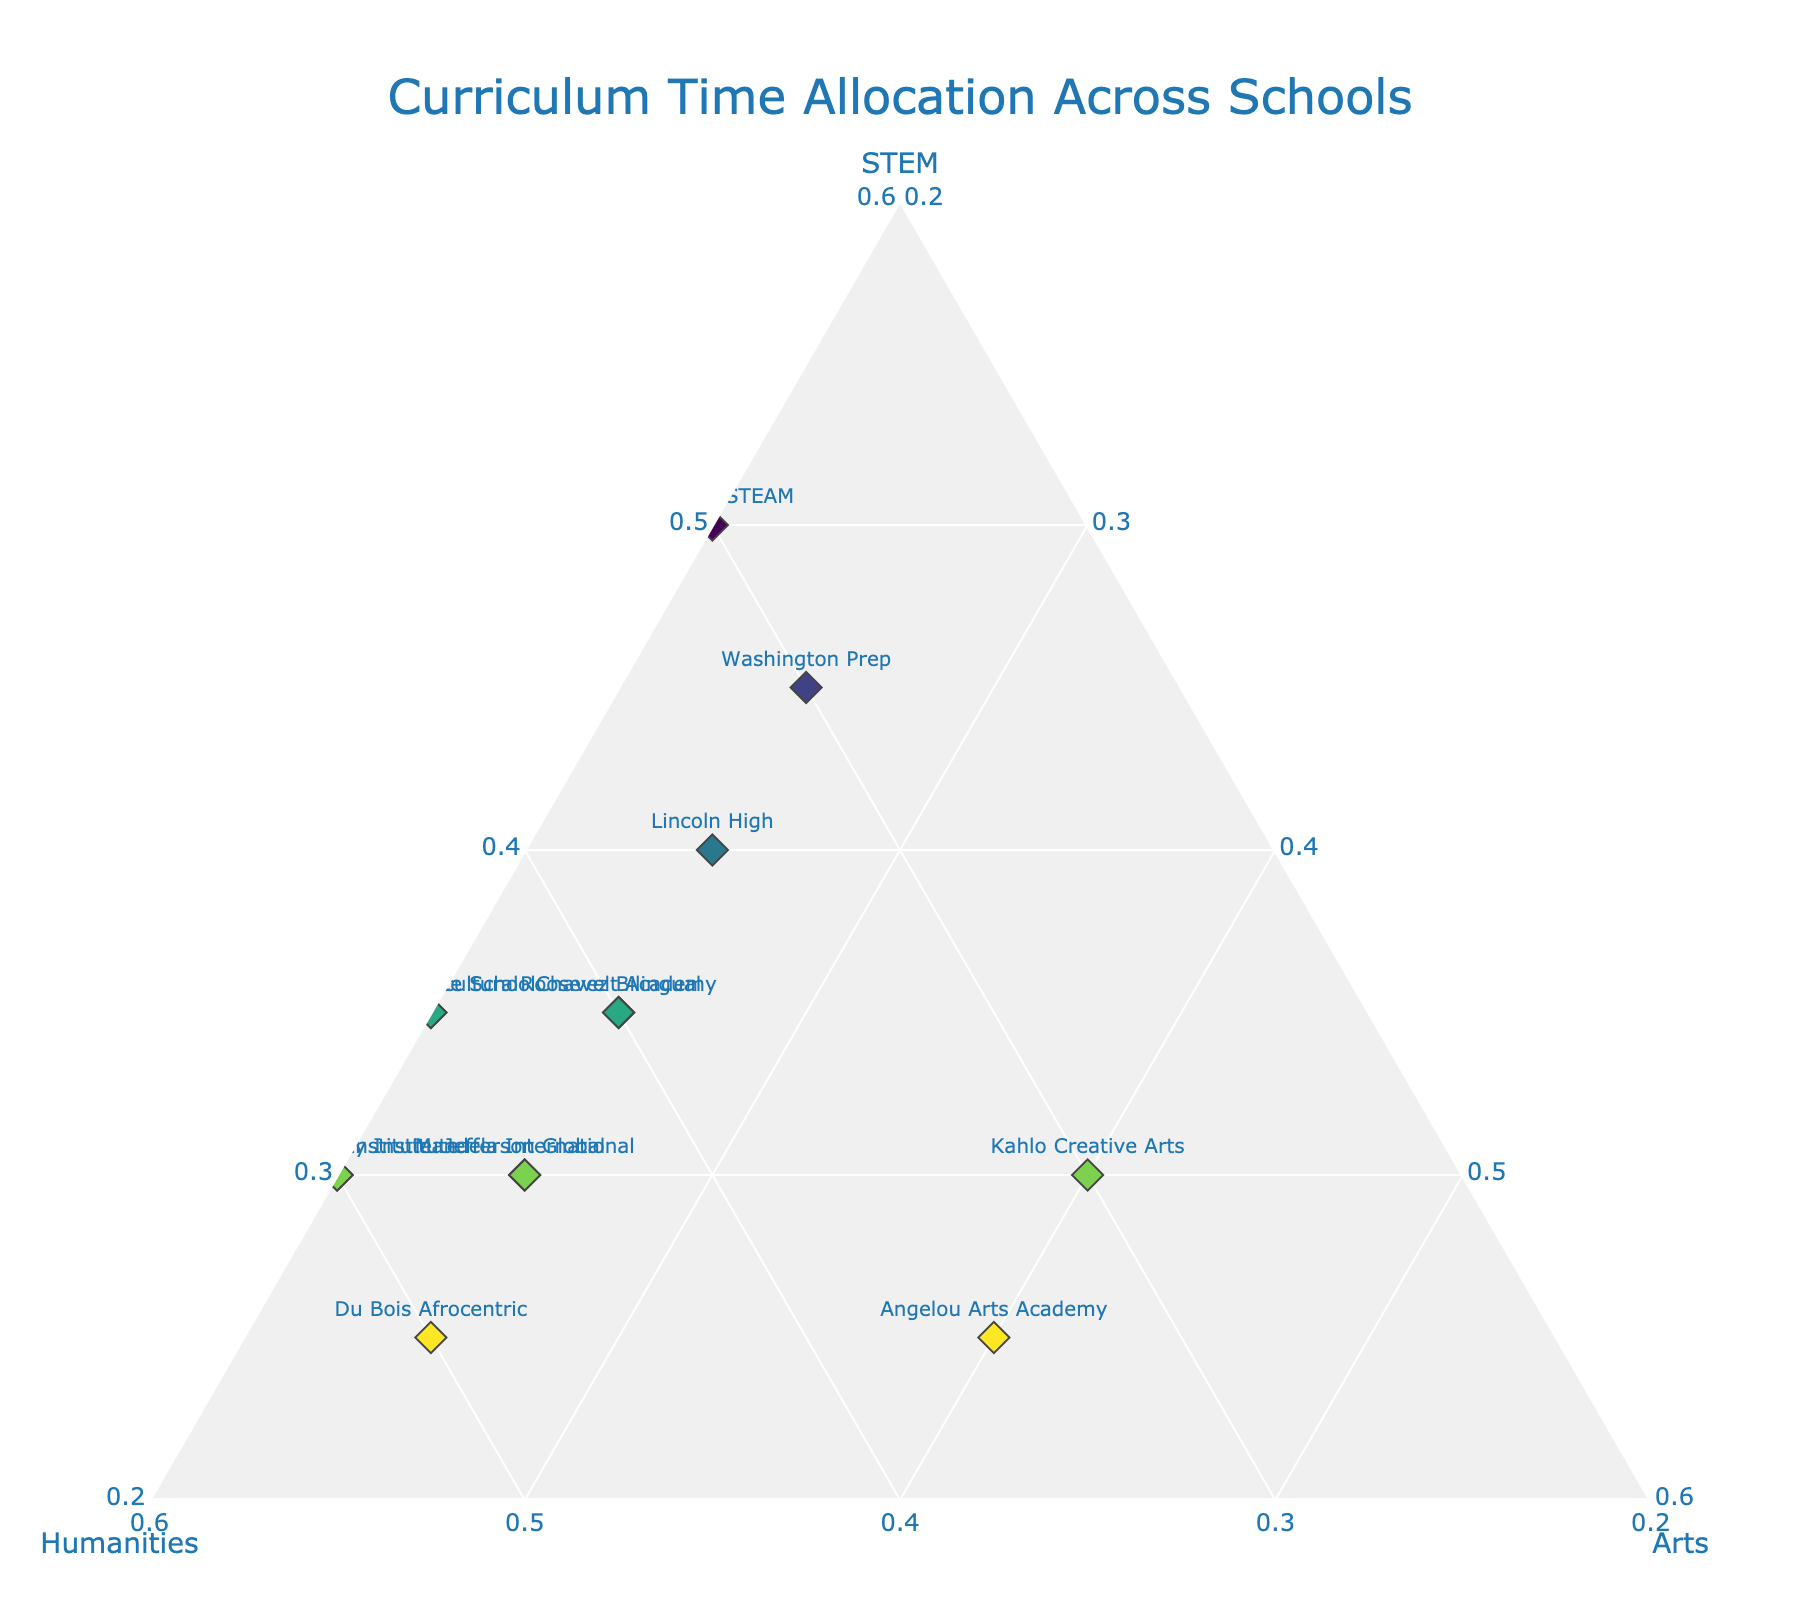What's the title of the figure? The title is placed at the top of the figure and usually summarizes the content. In this case, the title is "Curriculum Time Allocation Across Schools" as stated in the data description.
Answer: Curriculum Time Allocation Across Schools Which school allocates the most time to STEM? You need to find the point on the ternary plot with the highest value on the STEM axis. The school with the highest STEM allocation is Kennedy STEAM at 50%.
Answer: Kennedy STEAM What are the STEM and Humanities percentages for Lincoln High? Refer to the figure and locate the data point for Lincoln High. The percentages shown are 40% for STEM and 35% for Humanities.
Answer: 40% STEM and 35% Humanities Which schools have the highest allocation to the Arts? Look for the points on the ternary plot with the highest values on the Arts axis. Angelou Arts Academy and Kahlo Creative Arts both allocate 40% to Arts.
Answer: Angelou Arts Academy and Kahlo Creative Arts How does the Humanities allocation compare between King Multicultural and Jefferson Global? Compare the values on the Humanities axis for both schools. King Multicultural allocates 45% and Jefferson Global allocates 45% as well.
Answer: They are equal Which school has a balanced approach to STEM and Humanities allocation while also including Arts? A balanced approach means similar percentages in multiple categories. Roosevelt Academy allocates 35% to STEM, 40% to Humanities, and 25% to Arts, showing a balanced distribution.
Answer: Roosevelt Academy What is the total percentage allocated to non-STEM subjects at Chavez Bilingual? Sum the values for Humanities and Arts. Chavez Bilingual allocates 40% to Humanities and 25% to Arts, for a total of 65% to non-STEM subjects.
Answer: 65% Which school emphasizes cultural diversity the most based on Humanities allocation? Schools with the highest Humanities allocation emphasize cultural diversity. Parks Diversity Institute and Confucius Institute both allocate 50% to Humanities.
Answer: Parks Diversity Institute and Confucius Institute Compare the STEM and Arts allocation for Washington Prep and Mandela International. For Washington Prep, STEM is 45% and Arts is 25%. For Mandela International, STEM is 30% and Arts is 25%. Compare these values.
Answer: Washington Prep has higher STEM and both have equal Arts Identify a school with a strong emphasis on Humanities and Arts but less on STEM. A strong emphasis on Humanities and Arts means high percentages in these areas. Du Bois Afrocentric allocates 50% to Humanities and 25% to Arts with only 25% to STEM.
Answer: Du Bois Afrocentric 